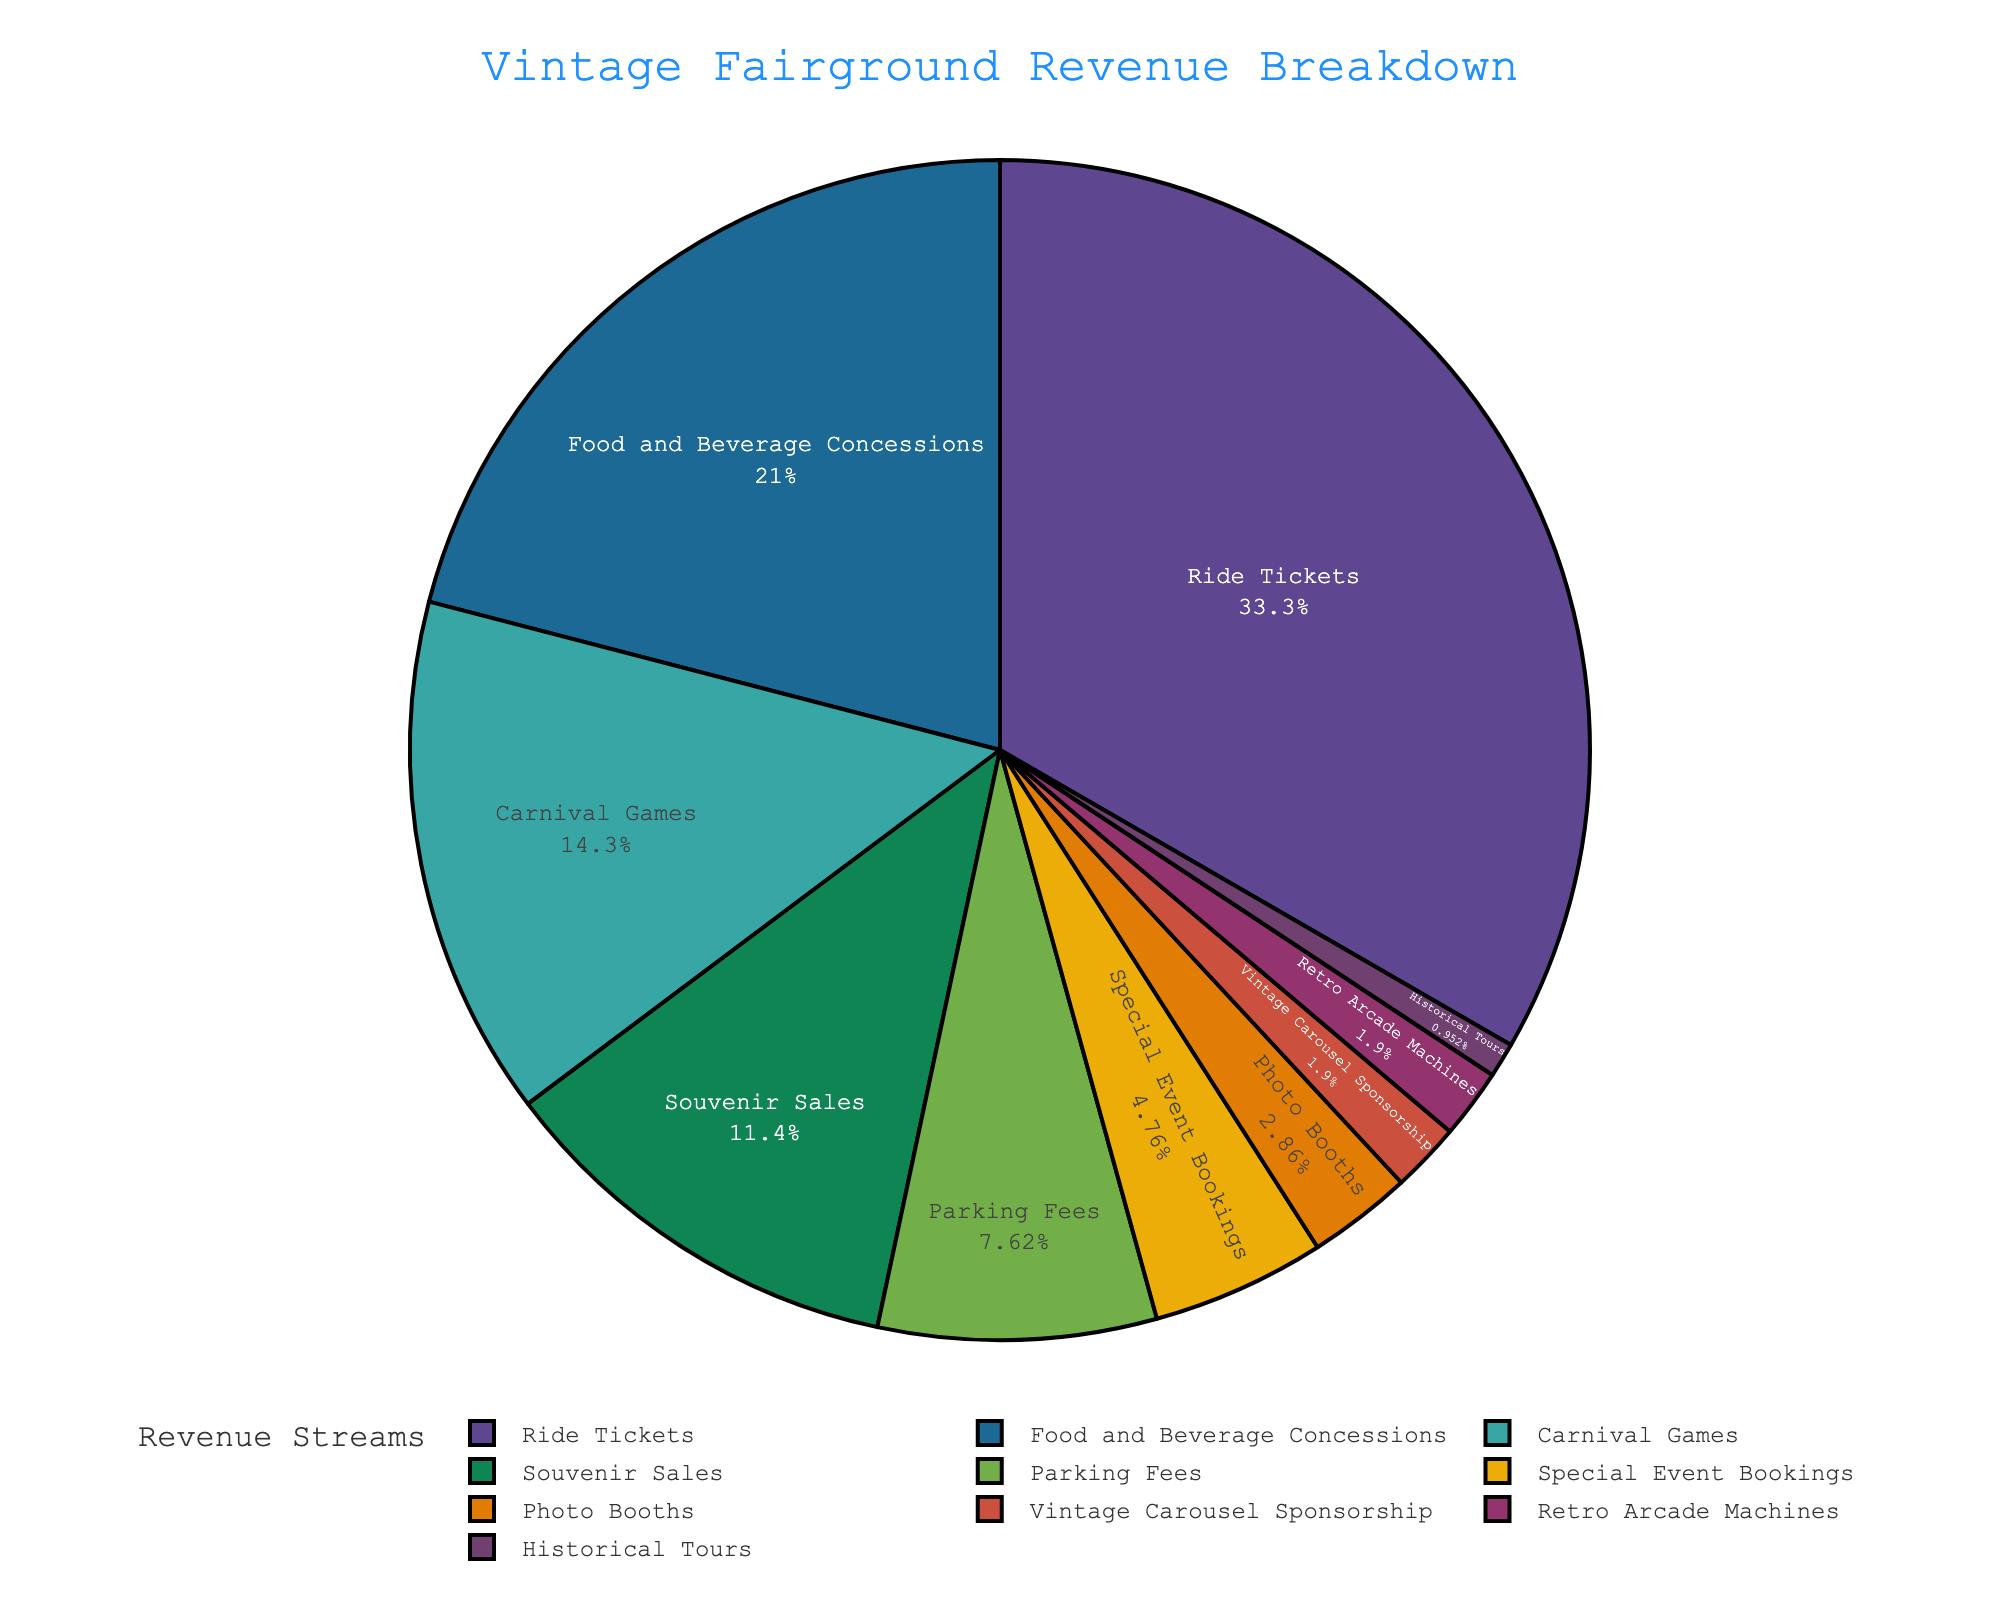Which revenue stream brings in the highest revenue? The pie chart shows that "Ride Tickets" have the largest segment.
Answer: Ride Tickets What percentage of the revenue comes from Food and Beverage Concessions? By looking at the labeled segments, the "Food and Beverage Concessions" section shows 22%.
Answer: 22% How much more revenue do Ride Tickets generate compared to Carnival Games? Ride Tickets bring in 35%, and Carnival Games bring in 15%. The difference is 35% - 15% = 20%.
Answer: 20% Combine the revenue from Souvenir Sales and Parking Fees. What is the total percentage? The pie chart shows Souvenir Sales at 12% and Parking Fees at 8%. The sum is 12% + 8% = 20%.
Answer: 20% What is the combined revenue percentage from the three least contributing streams? The smallest segments are: Historical Tours (1%), Retro Arcade Machines (2%), Vintage Carousel Sponsorship (2%). Adding them together: 1% + 2% + 2% = 5%.
Answer: 5% Which has a greater revenue share: Parking Fees or Carnival Games? The chart shows Parking Fees at 8% and Carnival Games at 15%. Carnival Games has a greater share.
Answer: Carnival Games Are there more revenue streams contributing less than 5% compared to those contributing more than 5%? Streams contributing less than 5%: Special Event Bookings, Photo Booths, Vintage Carousel Sponsorship, Retro Arcade Machines, Historical Tours (5 streams). Streams contributing more than 5%: Ride Tickets, Food and Beverage Concessions, Carnival Games, Souvenir Sales, Parking Fees (5 streams). The number of streams is equal for both.
Answer: No What percentage of revenue is generated by streams contributing at least 10%? Ride Tickets (35%) and Food and Beverage Concessions (22%) are the only streams contributing at least 10%. The sum is 35% + 22% = 57%.
Answer: 57% Which revenue stream is represented by the smallest slice in the pie chart? The chart shows the smallest slice labeled as "Historical Tours" at 1%.
Answer: Historical Tours What is the total percentage of revenue generated by Photo Booths, Retro Arcade Machines, and Historical Tours combined? The percentages are Photo Booths (3%), Retro Arcade Machines (2%), and Historical Tours (1%). The total is 3% + 2% + 1% = 6%.
Answer: 6% 